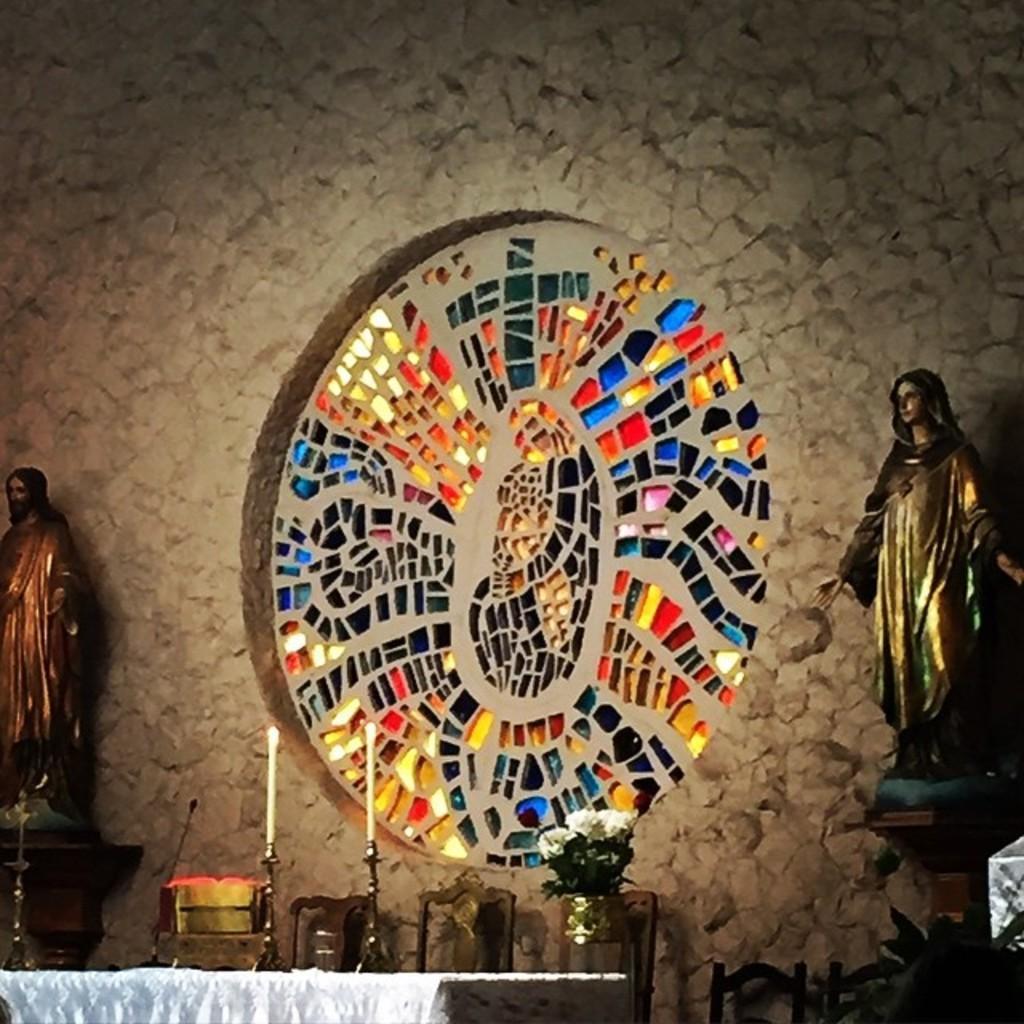Please provide a concise description of this image. In this image there is a wall decor in the circle shape on the wall made of some glass pieces in-front of that there are few sculptures, table and chairs. 